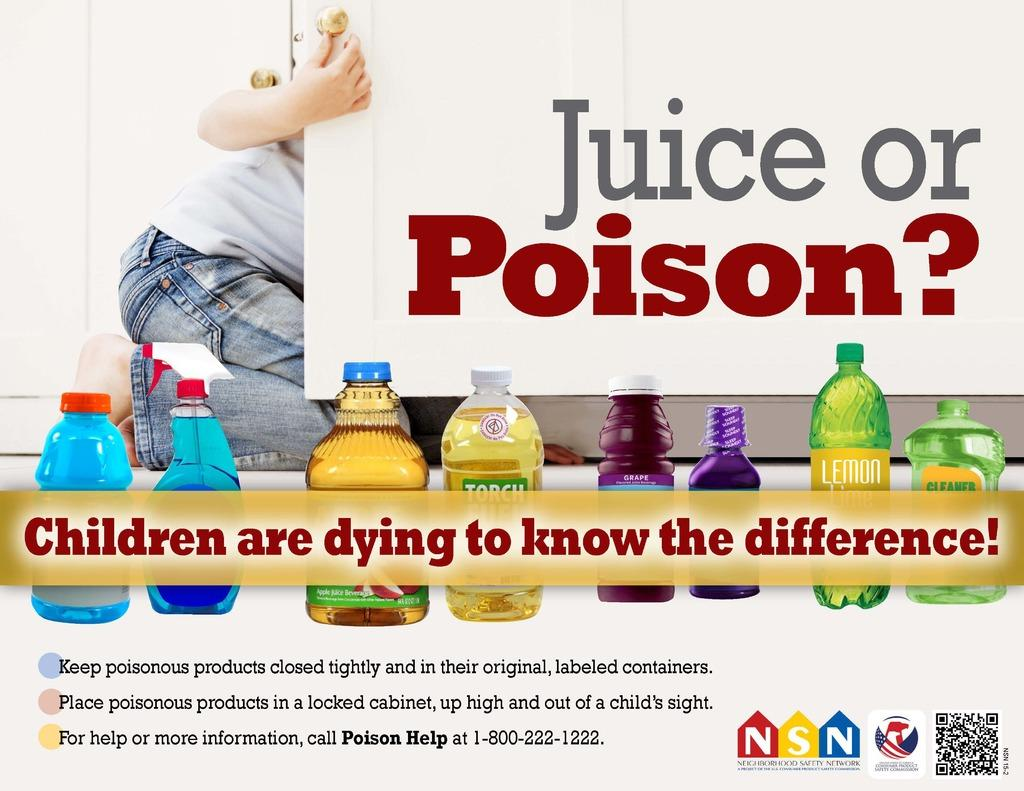<image>
Render a clear and concise summary of the photo. Ad saying "Juice or Poison?" on it showing a man looking inside a cabinet. 